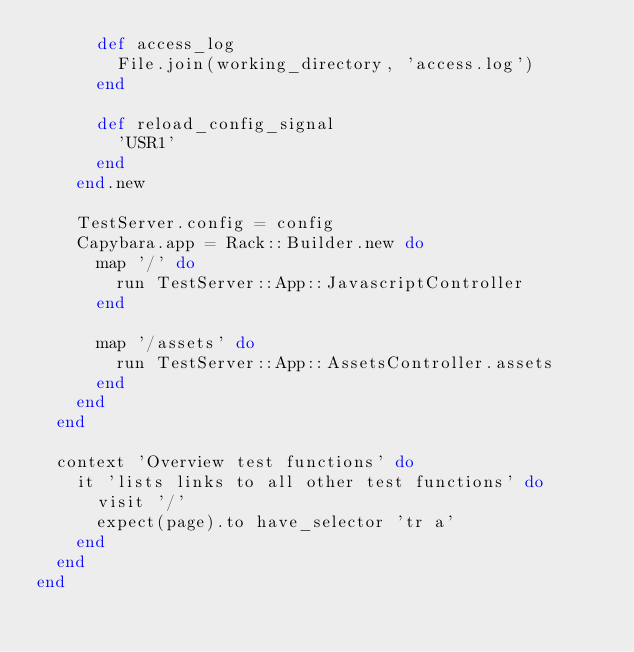Convert code to text. <code><loc_0><loc_0><loc_500><loc_500><_Ruby_>      def access_log 
        File.join(working_directory, 'access.log')
      end

      def reload_config_signal
        'USR1'
      end
    end.new

    TestServer.config = config
    Capybara.app = Rack::Builder.new do
      map '/' do
        run TestServer::App::JavascriptController
      end

      map '/assets' do
        run TestServer::App::AssetsController.assets
      end
    end
  end

  context 'Overview test functions' do
    it 'lists links to all other test functions' do
      visit '/'
      expect(page).to have_selector 'tr a'
    end
  end
end
</code> 